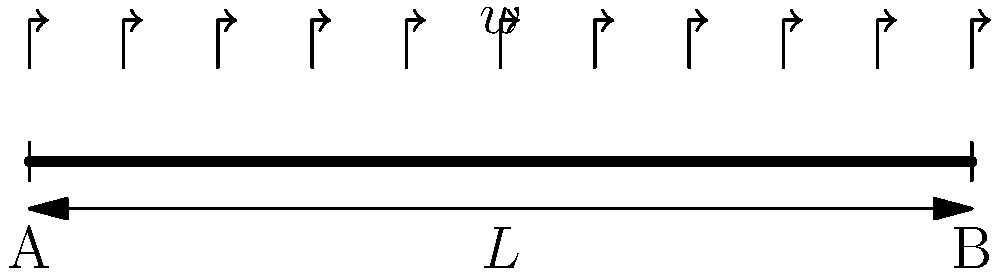A simply supported beam of length $L$ is subjected to a uniformly distributed load $w$ per unit length. Calculate the maximum bending stress $\sigma_{max}$ at the midspan of the beam if its cross-section is rectangular with width $b$ and height $h$. To calculate the maximum bending stress, we'll follow these steps:

1) First, determine the maximum bending moment $M_{max}$ at the midspan:
   $$M_{max} = \frac{wL^2}{8}$$

2) Calculate the moment of inertia $I$ for a rectangular cross-section:
   $$I = \frac{bh^3}{12}$$

3) Find the distance $y$ from the neutral axis to the extreme fiber:
   $$y = \frac{h}{2}$$

4) Use the flexure formula to calculate the maximum bending stress:
   $$\sigma_{max} = \frac{M_{max}y}{I}$$

5) Substitute the expressions for $M_{max}$, $I$, and $y$:
   $$\sigma_{max} = \frac{(\frac{wL^2}{8})(\frac{h}{2})}{(\frac{bh^3}{12})}$$

6) Simplify:
   $$\sigma_{max} = \frac{3wL^2}{4bh^2}$$

This equation gives the maximum bending stress at the midspan of the beam.
Answer: $$\sigma_{max} = \frac{3wL^2}{4bh^2}$$ 